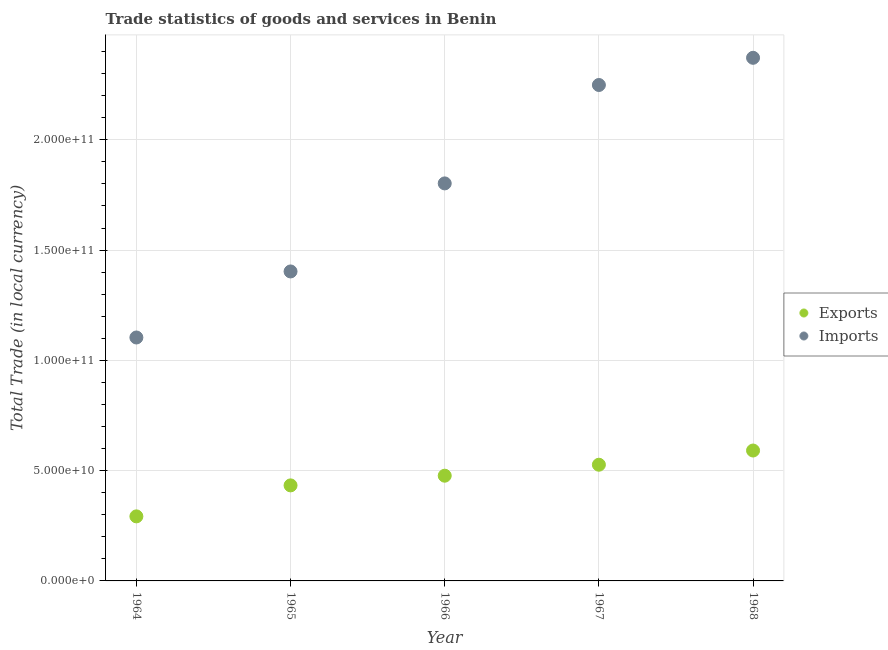How many different coloured dotlines are there?
Give a very brief answer. 2. Is the number of dotlines equal to the number of legend labels?
Provide a short and direct response. Yes. What is the imports of goods and services in 1965?
Offer a terse response. 1.40e+11. Across all years, what is the maximum export of goods and services?
Keep it short and to the point. 5.91e+1. Across all years, what is the minimum imports of goods and services?
Your answer should be very brief. 1.10e+11. In which year was the export of goods and services maximum?
Offer a very short reply. 1968. In which year was the export of goods and services minimum?
Provide a succinct answer. 1964. What is the total export of goods and services in the graph?
Provide a short and direct response. 2.32e+11. What is the difference between the export of goods and services in 1964 and that in 1965?
Keep it short and to the point. -1.40e+1. What is the difference between the export of goods and services in 1967 and the imports of goods and services in 1964?
Provide a short and direct response. -5.77e+1. What is the average imports of goods and services per year?
Offer a terse response. 1.79e+11. In the year 1965, what is the difference between the imports of goods and services and export of goods and services?
Make the answer very short. 9.70e+1. What is the ratio of the imports of goods and services in 1965 to that in 1967?
Your answer should be very brief. 0.62. What is the difference between the highest and the second highest export of goods and services?
Provide a succinct answer. 6.44e+09. What is the difference between the highest and the lowest imports of goods and services?
Ensure brevity in your answer.  1.27e+11. In how many years, is the export of goods and services greater than the average export of goods and services taken over all years?
Ensure brevity in your answer.  3. Is the sum of the imports of goods and services in 1966 and 1967 greater than the maximum export of goods and services across all years?
Provide a short and direct response. Yes. What is the difference between two consecutive major ticks on the Y-axis?
Your answer should be very brief. 5.00e+1. Where does the legend appear in the graph?
Provide a short and direct response. Center right. How are the legend labels stacked?
Your response must be concise. Vertical. What is the title of the graph?
Give a very brief answer. Trade statistics of goods and services in Benin. What is the label or title of the Y-axis?
Give a very brief answer. Total Trade (in local currency). What is the Total Trade (in local currency) in Exports in 1964?
Your answer should be compact. 2.93e+1. What is the Total Trade (in local currency) in Imports in 1964?
Offer a very short reply. 1.10e+11. What is the Total Trade (in local currency) of Exports in 1965?
Your response must be concise. 4.33e+1. What is the Total Trade (in local currency) of Imports in 1965?
Your answer should be very brief. 1.40e+11. What is the Total Trade (in local currency) of Exports in 1966?
Your response must be concise. 4.77e+1. What is the Total Trade (in local currency) in Imports in 1966?
Provide a succinct answer. 1.80e+11. What is the Total Trade (in local currency) in Exports in 1967?
Provide a succinct answer. 5.27e+1. What is the Total Trade (in local currency) in Imports in 1967?
Offer a terse response. 2.25e+11. What is the Total Trade (in local currency) of Exports in 1968?
Provide a succinct answer. 5.91e+1. What is the Total Trade (in local currency) in Imports in 1968?
Provide a short and direct response. 2.37e+11. Across all years, what is the maximum Total Trade (in local currency) in Exports?
Your answer should be very brief. 5.91e+1. Across all years, what is the maximum Total Trade (in local currency) of Imports?
Your answer should be compact. 2.37e+11. Across all years, what is the minimum Total Trade (in local currency) of Exports?
Ensure brevity in your answer.  2.93e+1. Across all years, what is the minimum Total Trade (in local currency) in Imports?
Your response must be concise. 1.10e+11. What is the total Total Trade (in local currency) of Exports in the graph?
Make the answer very short. 2.32e+11. What is the total Total Trade (in local currency) in Imports in the graph?
Your response must be concise. 8.93e+11. What is the difference between the Total Trade (in local currency) in Exports in 1964 and that in 1965?
Provide a succinct answer. -1.40e+1. What is the difference between the Total Trade (in local currency) in Imports in 1964 and that in 1965?
Offer a terse response. -2.99e+1. What is the difference between the Total Trade (in local currency) in Exports in 1964 and that in 1966?
Give a very brief answer. -1.84e+1. What is the difference between the Total Trade (in local currency) of Imports in 1964 and that in 1966?
Your response must be concise. -6.99e+1. What is the difference between the Total Trade (in local currency) in Exports in 1964 and that in 1967?
Provide a succinct answer. -2.34e+1. What is the difference between the Total Trade (in local currency) in Imports in 1964 and that in 1967?
Offer a very short reply. -1.14e+11. What is the difference between the Total Trade (in local currency) in Exports in 1964 and that in 1968?
Offer a very short reply. -2.99e+1. What is the difference between the Total Trade (in local currency) in Imports in 1964 and that in 1968?
Make the answer very short. -1.27e+11. What is the difference between the Total Trade (in local currency) in Exports in 1965 and that in 1966?
Keep it short and to the point. -4.39e+09. What is the difference between the Total Trade (in local currency) in Imports in 1965 and that in 1966?
Give a very brief answer. -3.99e+1. What is the difference between the Total Trade (in local currency) of Exports in 1965 and that in 1967?
Provide a short and direct response. -9.37e+09. What is the difference between the Total Trade (in local currency) in Imports in 1965 and that in 1967?
Make the answer very short. -8.45e+1. What is the difference between the Total Trade (in local currency) in Exports in 1965 and that in 1968?
Provide a succinct answer. -1.58e+1. What is the difference between the Total Trade (in local currency) of Imports in 1965 and that in 1968?
Give a very brief answer. -9.69e+1. What is the difference between the Total Trade (in local currency) in Exports in 1966 and that in 1967?
Make the answer very short. -4.98e+09. What is the difference between the Total Trade (in local currency) in Imports in 1966 and that in 1967?
Keep it short and to the point. -4.46e+1. What is the difference between the Total Trade (in local currency) of Exports in 1966 and that in 1968?
Provide a short and direct response. -1.14e+1. What is the difference between the Total Trade (in local currency) in Imports in 1966 and that in 1968?
Your response must be concise. -5.69e+1. What is the difference between the Total Trade (in local currency) of Exports in 1967 and that in 1968?
Your response must be concise. -6.44e+09. What is the difference between the Total Trade (in local currency) of Imports in 1967 and that in 1968?
Your answer should be very brief. -1.23e+1. What is the difference between the Total Trade (in local currency) of Exports in 1964 and the Total Trade (in local currency) of Imports in 1965?
Your answer should be compact. -1.11e+11. What is the difference between the Total Trade (in local currency) in Exports in 1964 and the Total Trade (in local currency) in Imports in 1966?
Your answer should be very brief. -1.51e+11. What is the difference between the Total Trade (in local currency) of Exports in 1964 and the Total Trade (in local currency) of Imports in 1967?
Offer a very short reply. -1.96e+11. What is the difference between the Total Trade (in local currency) of Exports in 1964 and the Total Trade (in local currency) of Imports in 1968?
Your answer should be compact. -2.08e+11. What is the difference between the Total Trade (in local currency) in Exports in 1965 and the Total Trade (in local currency) in Imports in 1966?
Your response must be concise. -1.37e+11. What is the difference between the Total Trade (in local currency) of Exports in 1965 and the Total Trade (in local currency) of Imports in 1967?
Your answer should be very brief. -1.82e+11. What is the difference between the Total Trade (in local currency) of Exports in 1965 and the Total Trade (in local currency) of Imports in 1968?
Give a very brief answer. -1.94e+11. What is the difference between the Total Trade (in local currency) in Exports in 1966 and the Total Trade (in local currency) in Imports in 1967?
Make the answer very short. -1.77e+11. What is the difference between the Total Trade (in local currency) in Exports in 1966 and the Total Trade (in local currency) in Imports in 1968?
Offer a very short reply. -1.89e+11. What is the difference between the Total Trade (in local currency) of Exports in 1967 and the Total Trade (in local currency) of Imports in 1968?
Offer a terse response. -1.84e+11. What is the average Total Trade (in local currency) of Exports per year?
Provide a short and direct response. 4.64e+1. What is the average Total Trade (in local currency) of Imports per year?
Keep it short and to the point. 1.79e+11. In the year 1964, what is the difference between the Total Trade (in local currency) in Exports and Total Trade (in local currency) in Imports?
Your answer should be compact. -8.11e+1. In the year 1965, what is the difference between the Total Trade (in local currency) in Exports and Total Trade (in local currency) in Imports?
Give a very brief answer. -9.70e+1. In the year 1966, what is the difference between the Total Trade (in local currency) in Exports and Total Trade (in local currency) in Imports?
Your response must be concise. -1.33e+11. In the year 1967, what is the difference between the Total Trade (in local currency) of Exports and Total Trade (in local currency) of Imports?
Give a very brief answer. -1.72e+11. In the year 1968, what is the difference between the Total Trade (in local currency) of Exports and Total Trade (in local currency) of Imports?
Provide a succinct answer. -1.78e+11. What is the ratio of the Total Trade (in local currency) of Exports in 1964 to that in 1965?
Offer a very short reply. 0.68. What is the ratio of the Total Trade (in local currency) in Imports in 1964 to that in 1965?
Your response must be concise. 0.79. What is the ratio of the Total Trade (in local currency) of Exports in 1964 to that in 1966?
Keep it short and to the point. 0.61. What is the ratio of the Total Trade (in local currency) in Imports in 1964 to that in 1966?
Ensure brevity in your answer.  0.61. What is the ratio of the Total Trade (in local currency) in Exports in 1964 to that in 1967?
Your response must be concise. 0.56. What is the ratio of the Total Trade (in local currency) of Imports in 1964 to that in 1967?
Provide a succinct answer. 0.49. What is the ratio of the Total Trade (in local currency) of Exports in 1964 to that in 1968?
Give a very brief answer. 0.49. What is the ratio of the Total Trade (in local currency) of Imports in 1964 to that in 1968?
Make the answer very short. 0.47. What is the ratio of the Total Trade (in local currency) in Exports in 1965 to that in 1966?
Give a very brief answer. 0.91. What is the ratio of the Total Trade (in local currency) in Imports in 1965 to that in 1966?
Make the answer very short. 0.78. What is the ratio of the Total Trade (in local currency) of Exports in 1965 to that in 1967?
Make the answer very short. 0.82. What is the ratio of the Total Trade (in local currency) in Imports in 1965 to that in 1967?
Provide a succinct answer. 0.62. What is the ratio of the Total Trade (in local currency) of Exports in 1965 to that in 1968?
Provide a succinct answer. 0.73. What is the ratio of the Total Trade (in local currency) in Imports in 1965 to that in 1968?
Provide a short and direct response. 0.59. What is the ratio of the Total Trade (in local currency) of Exports in 1966 to that in 1967?
Your response must be concise. 0.91. What is the ratio of the Total Trade (in local currency) of Imports in 1966 to that in 1967?
Make the answer very short. 0.8. What is the ratio of the Total Trade (in local currency) of Exports in 1966 to that in 1968?
Ensure brevity in your answer.  0.81. What is the ratio of the Total Trade (in local currency) of Imports in 1966 to that in 1968?
Provide a short and direct response. 0.76. What is the ratio of the Total Trade (in local currency) of Exports in 1967 to that in 1968?
Offer a terse response. 0.89. What is the ratio of the Total Trade (in local currency) of Imports in 1967 to that in 1968?
Your answer should be very brief. 0.95. What is the difference between the highest and the second highest Total Trade (in local currency) in Exports?
Offer a very short reply. 6.44e+09. What is the difference between the highest and the second highest Total Trade (in local currency) of Imports?
Your answer should be very brief. 1.23e+1. What is the difference between the highest and the lowest Total Trade (in local currency) of Exports?
Your answer should be very brief. 2.99e+1. What is the difference between the highest and the lowest Total Trade (in local currency) in Imports?
Provide a succinct answer. 1.27e+11. 